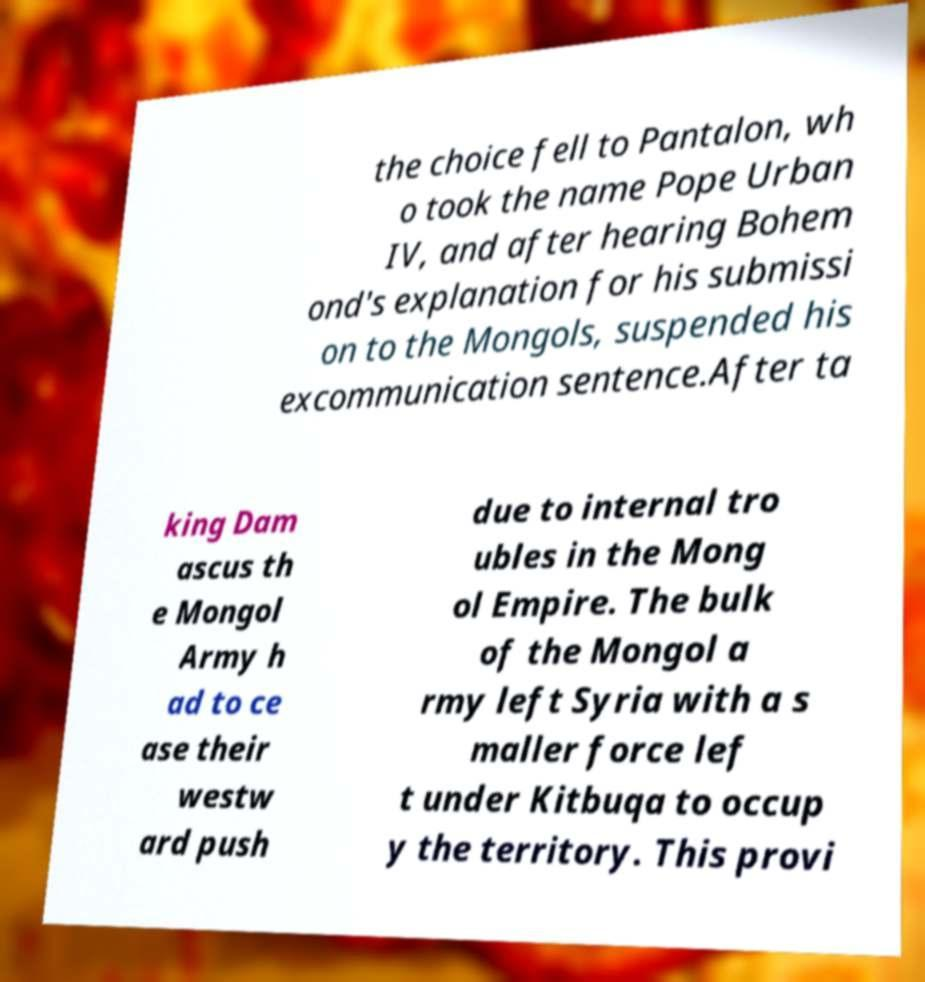There's text embedded in this image that I need extracted. Can you transcribe it verbatim? the choice fell to Pantalon, wh o took the name Pope Urban IV, and after hearing Bohem ond's explanation for his submissi on to the Mongols, suspended his excommunication sentence.After ta king Dam ascus th e Mongol Army h ad to ce ase their westw ard push due to internal tro ubles in the Mong ol Empire. The bulk of the Mongol a rmy left Syria with a s maller force lef t under Kitbuqa to occup y the territory. This provi 